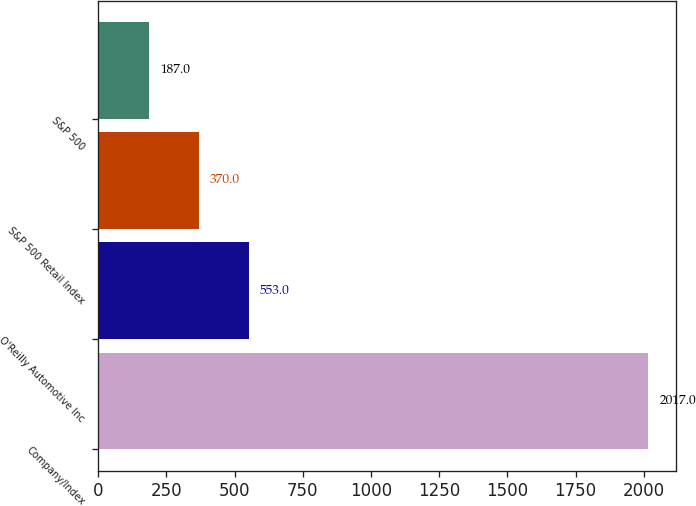<chart> <loc_0><loc_0><loc_500><loc_500><bar_chart><fcel>Company/Index<fcel>O'Reilly Automotive Inc<fcel>S&P 500 Retail Index<fcel>S&P 500<nl><fcel>2017<fcel>553<fcel>370<fcel>187<nl></chart> 